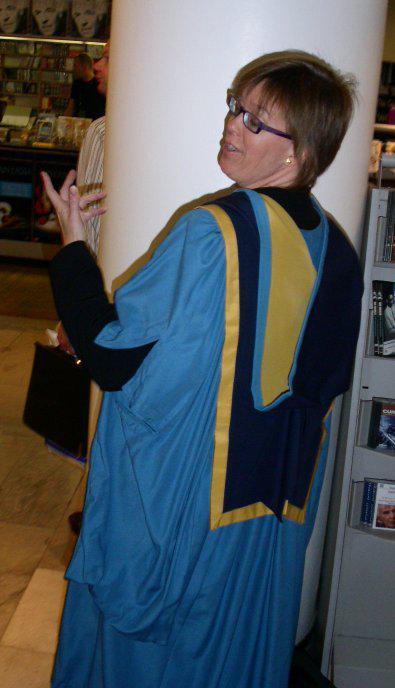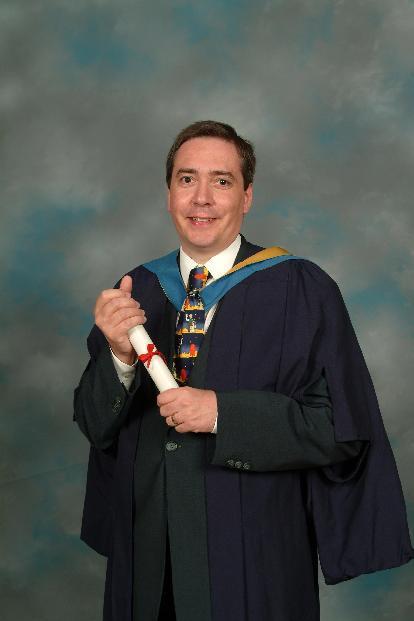The first image is the image on the left, the second image is the image on the right. Evaluate the accuracy of this statement regarding the images: "A smiling woman with short hair is seen from the front wearing a sky blue gown, open to show her clothing, with dark navy blue and yellow at her neck.". Is it true? Answer yes or no. No. The first image is the image on the left, the second image is the image on the right. Analyze the images presented: Is the assertion "One of the images shows a man wearing a blue and yellow stole holding a rolled up diploma in his hands that is tied with a red ribbon." valid? Answer yes or no. Yes. 